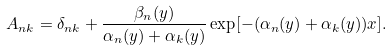Convert formula to latex. <formula><loc_0><loc_0><loc_500><loc_500>A _ { n k } = \delta _ { n k } + \frac { \beta _ { n } ( y ) } { \alpha _ { n } ( y ) + \alpha _ { k } ( y ) } \exp [ - ( \alpha _ { n } ( y ) + \alpha _ { k } ( y ) ) x ] .</formula> 